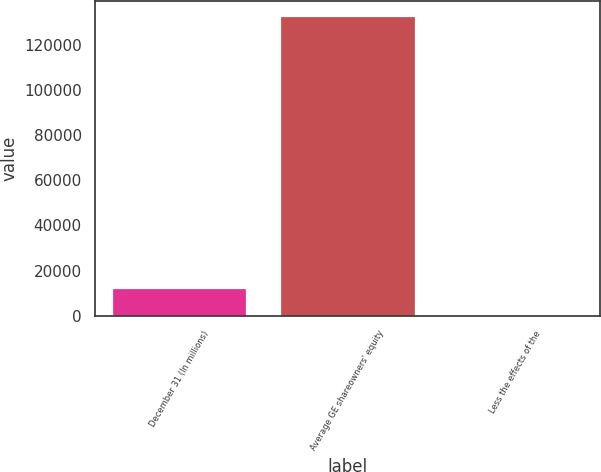Convert chart to OTSL. <chart><loc_0><loc_0><loc_500><loc_500><bar_chart><fcel>December 31 (In millions)<fcel>Average GE shareowners' equity<fcel>Less the effects of the<nl><fcel>12519.1<fcel>132452<fcel>478<nl></chart> 